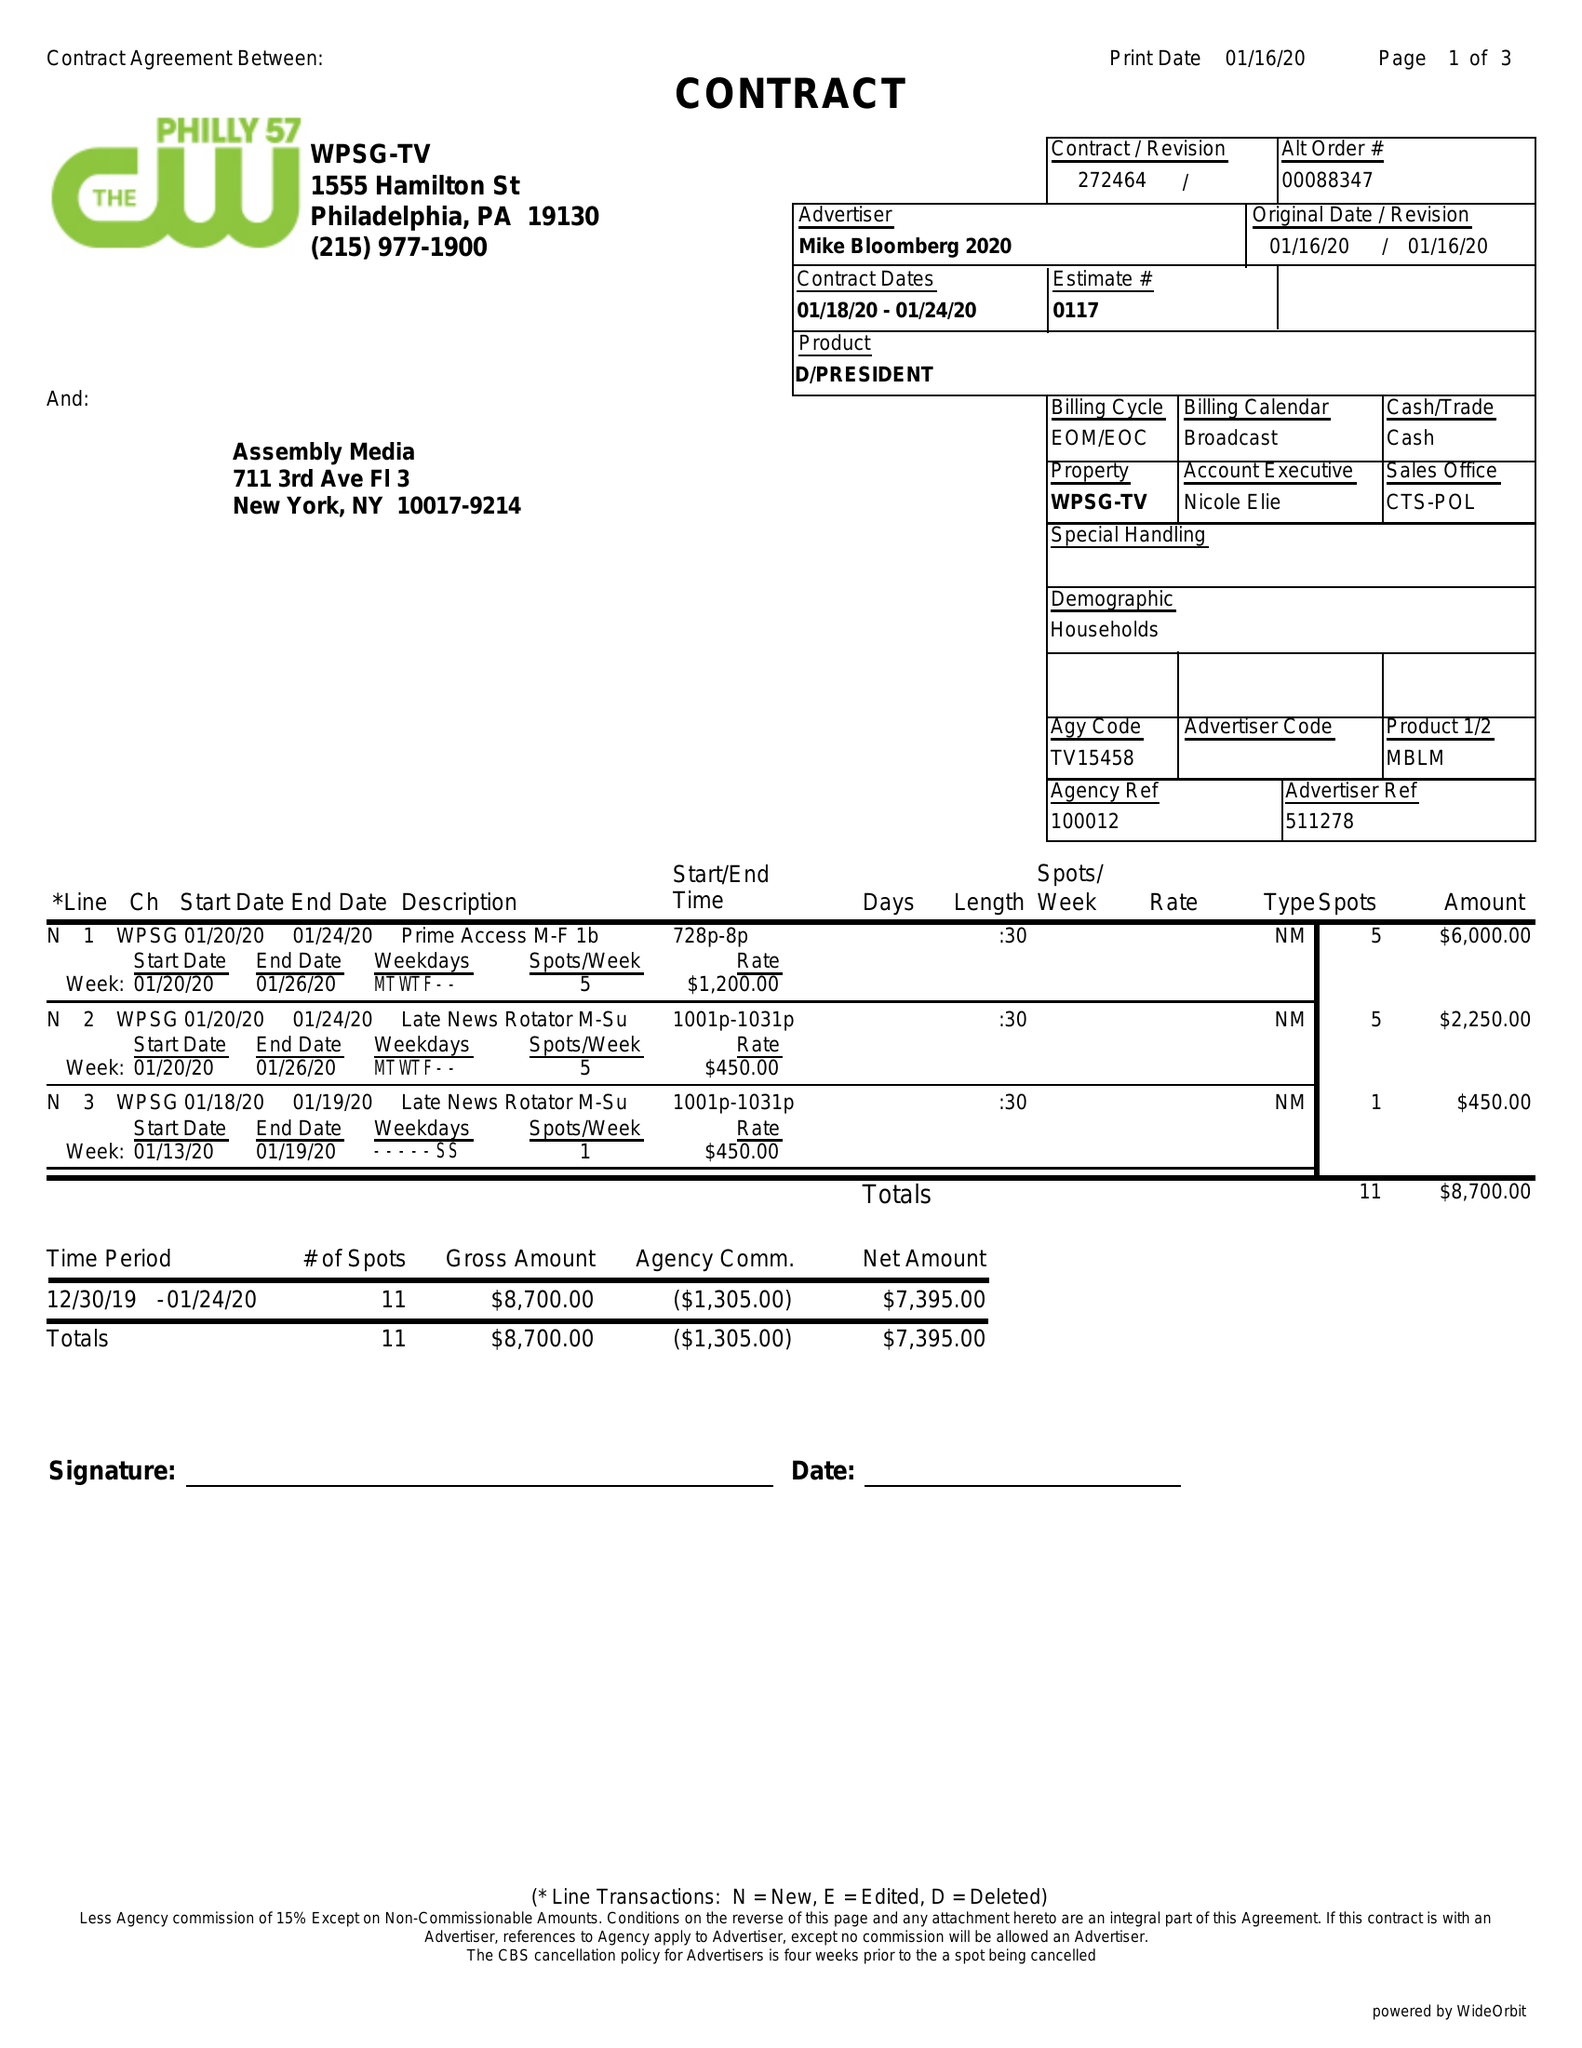What is the value for the gross_amount?
Answer the question using a single word or phrase. 8700.00 